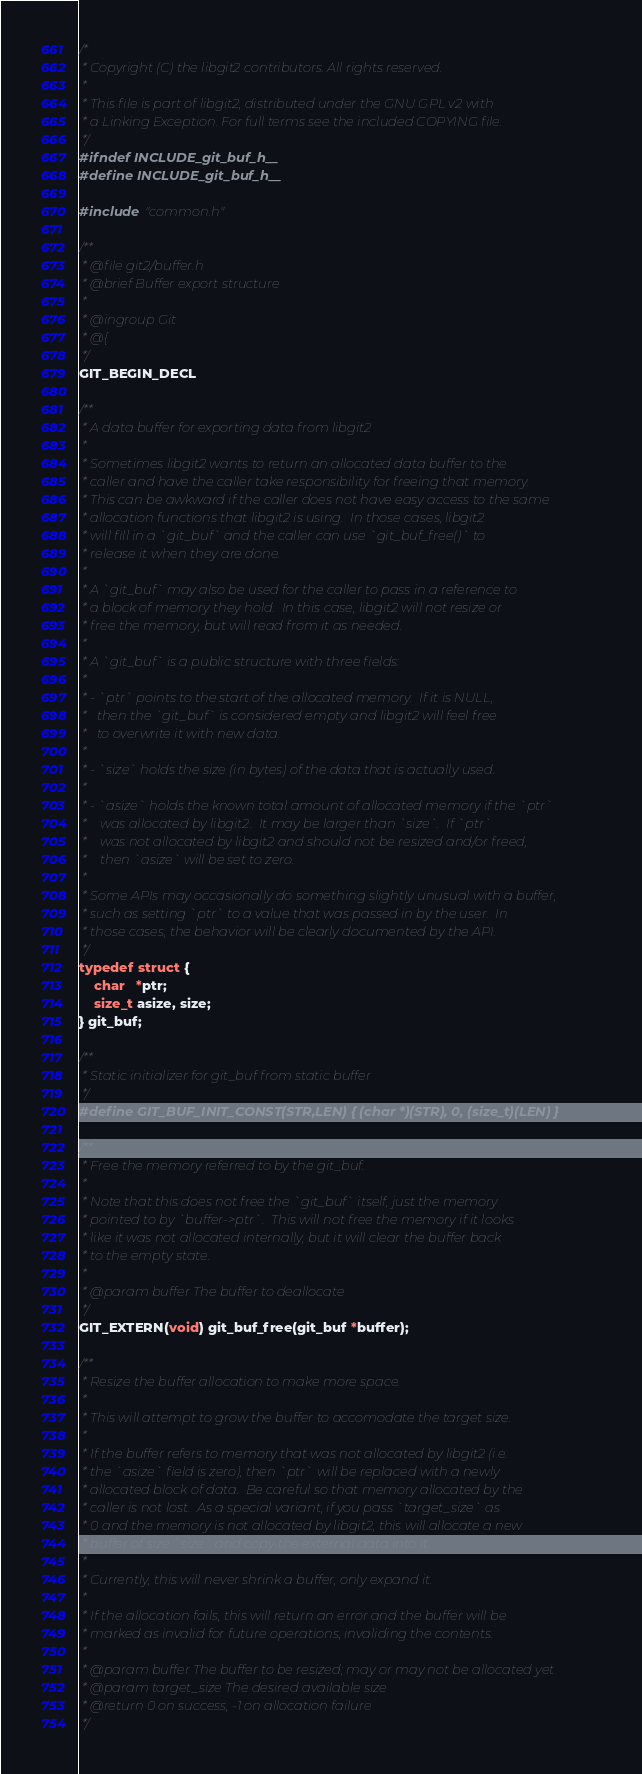Convert code to text. <code><loc_0><loc_0><loc_500><loc_500><_C_>/*
 * Copyright (C) the libgit2 contributors. All rights reserved.
 *
 * This file is part of libgit2, distributed under the GNU GPL v2 with
 * a Linking Exception. For full terms see the included COPYING file.
 */
#ifndef INCLUDE_git_buf_h__
#define INCLUDE_git_buf_h__

#include "common.h"

/**
 * @file git2/buffer.h
 * @brief Buffer export structure
 *
 * @ingroup Git
 * @{
 */
GIT_BEGIN_DECL

/**
 * A data buffer for exporting data from libgit2
 *
 * Sometimes libgit2 wants to return an allocated data buffer to the
 * caller and have the caller take responsibility for freeing that memory.
 * This can be awkward if the caller does not have easy access to the same
 * allocation functions that libgit2 is using.  In those cases, libgit2
 * will fill in a `git_buf` and the caller can use `git_buf_free()` to
 * release it when they are done.
 *
 * A `git_buf` may also be used for the caller to pass in a reference to
 * a block of memory they hold.  In this case, libgit2 will not resize or
 * free the memory, but will read from it as needed.
 *
 * A `git_buf` is a public structure with three fields:
 *
 * - `ptr` points to the start of the allocated memory.  If it is NULL,
 *   then the `git_buf` is considered empty and libgit2 will feel free
 *   to overwrite it with new data.
 *
 * - `size` holds the size (in bytes) of the data that is actually used.
 *
 * - `asize` holds the known total amount of allocated memory if the `ptr`
 *    was allocated by libgit2.  It may be larger than `size`.  If `ptr`
 *    was not allocated by libgit2 and should not be resized and/or freed,
 *    then `asize` will be set to zero.
 *
 * Some APIs may occasionally do something slightly unusual with a buffer,
 * such as setting `ptr` to a value that was passed in by the user.  In
 * those cases, the behavior will be clearly documented by the API.
 */
typedef struct {
	char   *ptr;
	size_t asize, size;
} git_buf;

/**
 * Static initializer for git_buf from static buffer
 */
#define GIT_BUF_INIT_CONST(STR,LEN) { (char *)(STR), 0, (size_t)(LEN) }

/**
 * Free the memory referred to by the git_buf.
 *
 * Note that this does not free the `git_buf` itself, just the memory
 * pointed to by `buffer->ptr`.  This will not free the memory if it looks
 * like it was not allocated internally, but it will clear the buffer back
 * to the empty state.
 *
 * @param buffer The buffer to deallocate
 */
GIT_EXTERN(void) git_buf_free(git_buf *buffer);

/**
 * Resize the buffer allocation to make more space.
 *
 * This will attempt to grow the buffer to accomodate the target size.
 *
 * If the buffer refers to memory that was not allocated by libgit2 (i.e.
 * the `asize` field is zero), then `ptr` will be replaced with a newly
 * allocated block of data.  Be careful so that memory allocated by the
 * caller is not lost.  As a special variant, if you pass `target_size` as
 * 0 and the memory is not allocated by libgit2, this will allocate a new
 * buffer of size `size` and copy the external data into it.
 *
 * Currently, this will never shrink a buffer, only expand it.
 *
 * If the allocation fails, this will return an error and the buffer will be
 * marked as invalid for future operations, invaliding the contents.
 *
 * @param buffer The buffer to be resized; may or may not be allocated yet
 * @param target_size The desired available size
 * @return 0 on success, -1 on allocation failure
 */</code> 